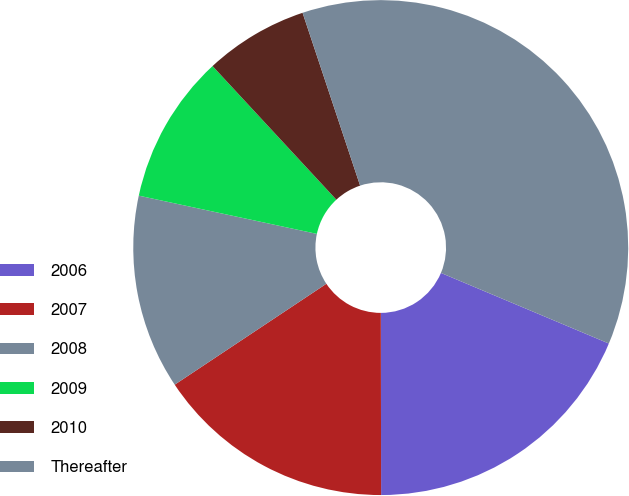Convert chart to OTSL. <chart><loc_0><loc_0><loc_500><loc_500><pie_chart><fcel>2006<fcel>2007<fcel>2008<fcel>2009<fcel>2010<fcel>Thereafter<nl><fcel>18.64%<fcel>15.68%<fcel>12.71%<fcel>9.74%<fcel>6.78%<fcel>36.45%<nl></chart> 